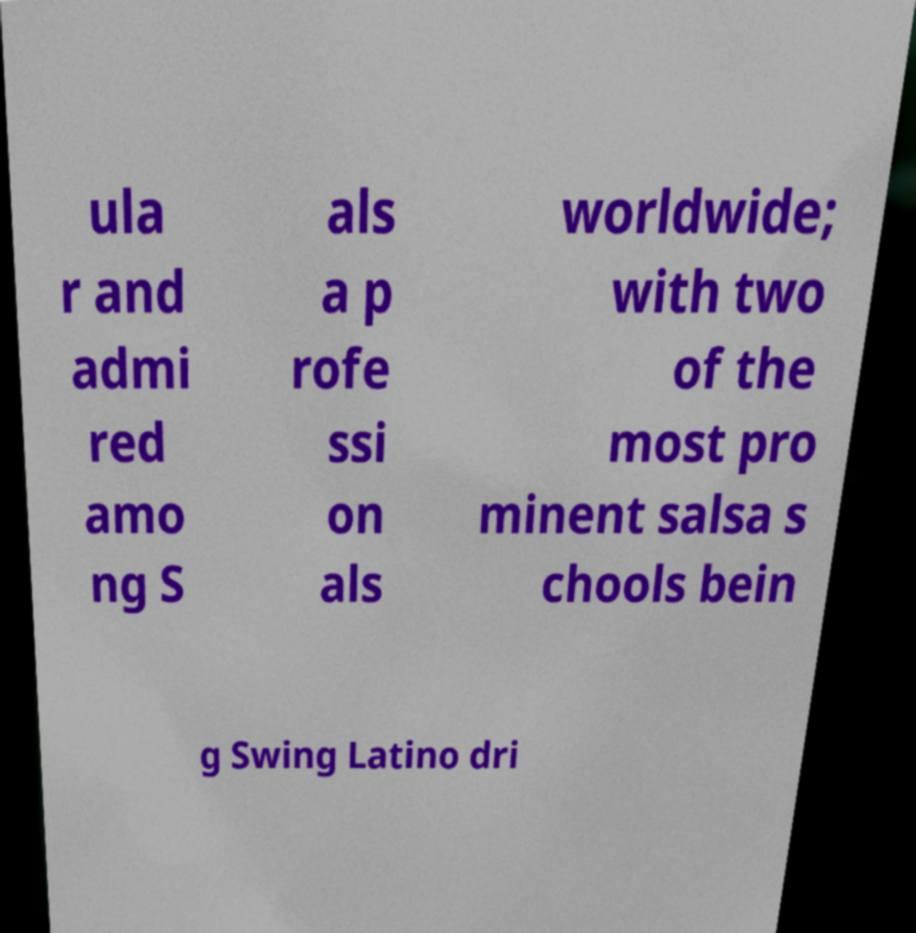Please identify and transcribe the text found in this image. ula r and admi red amo ng S als a p rofe ssi on als worldwide; with two of the most pro minent salsa s chools bein g Swing Latino dri 